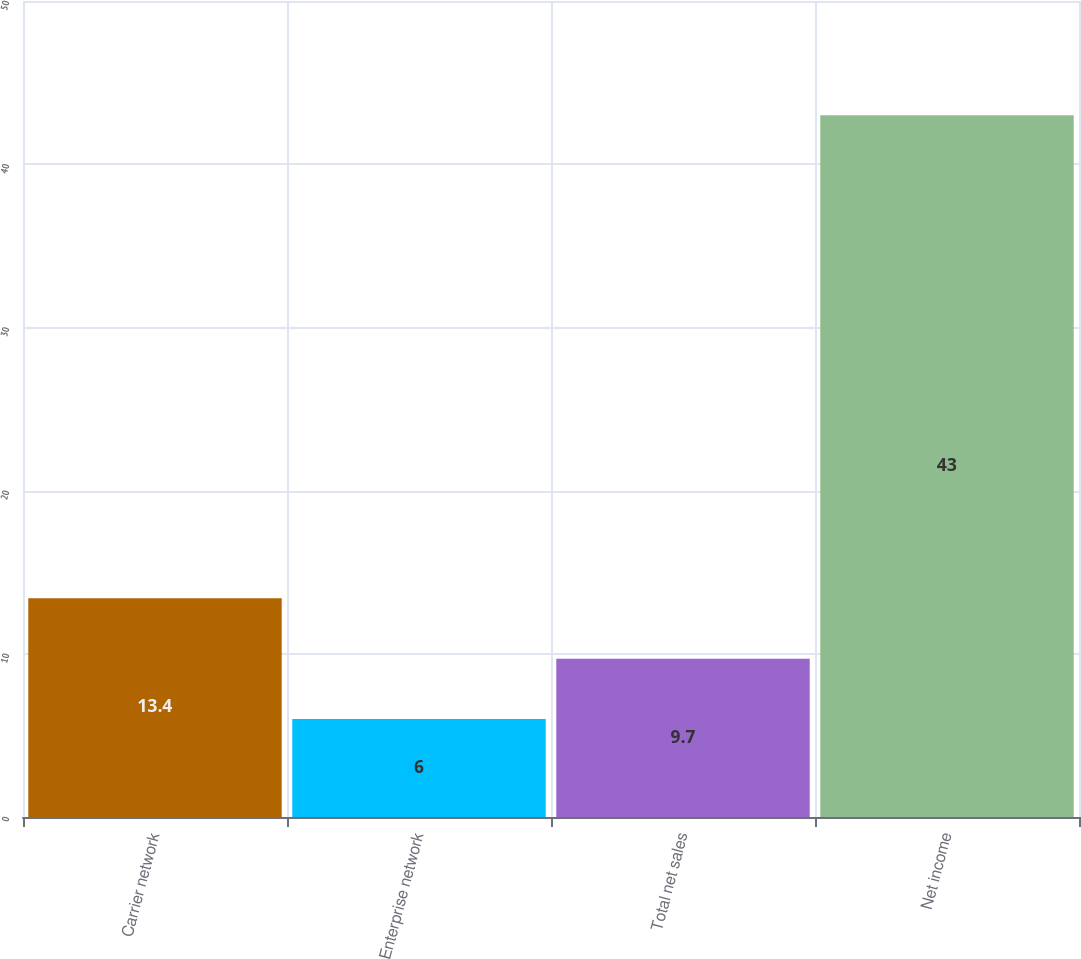<chart> <loc_0><loc_0><loc_500><loc_500><bar_chart><fcel>Carrier network<fcel>Enterprise network<fcel>Total net sales<fcel>Net income<nl><fcel>13.4<fcel>6<fcel>9.7<fcel>43<nl></chart> 